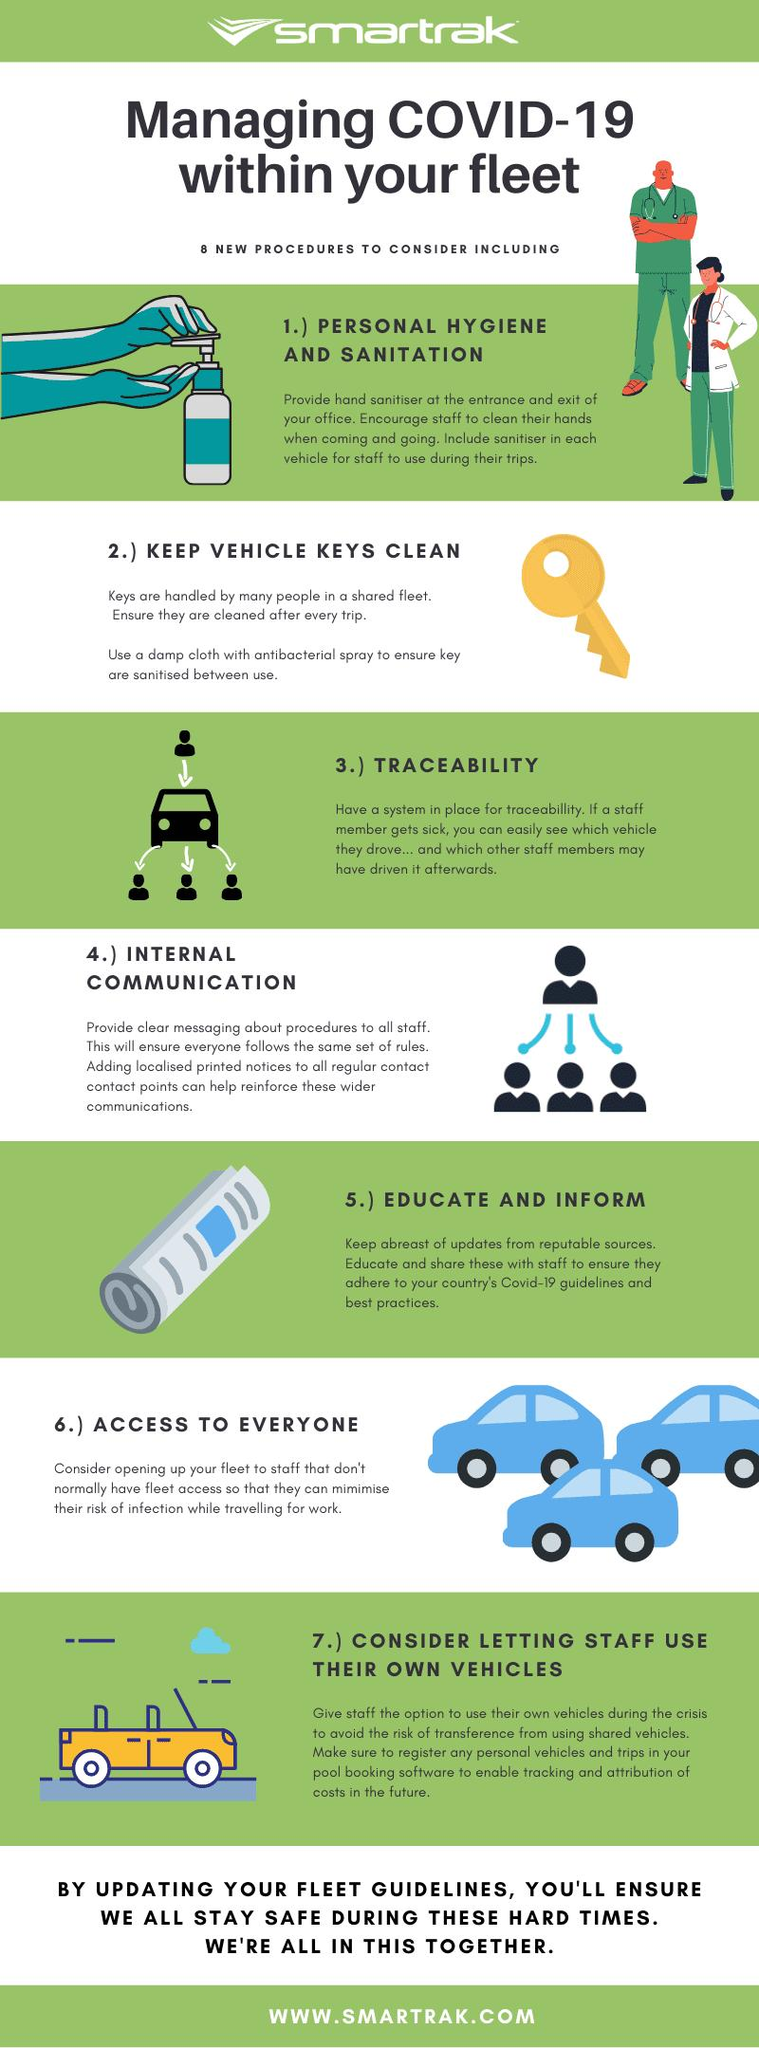Draw attention to some important aspects in this diagram. Providing hand sanitizer at the entrance and exit covers the procedure of personal hygiene and sanitation. The color of the key is yellow. 